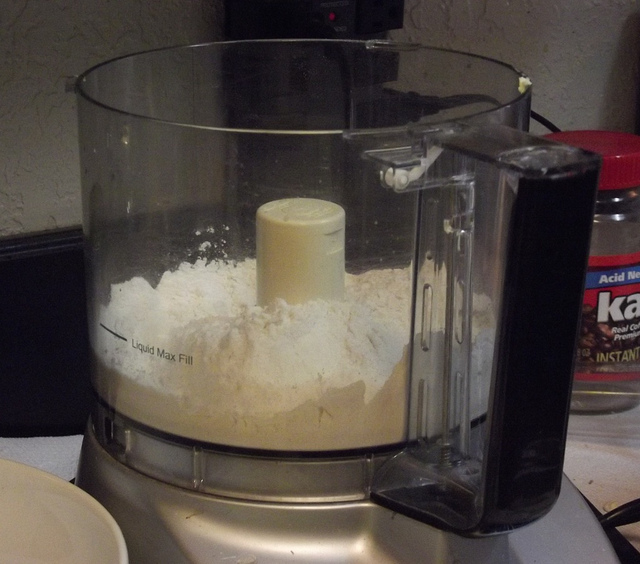<image>What is the brand name of the blender? I don't know the brand name of the blender. However, options are 'liquid max', 'logic max', 'kenmore', 'kitchenaid', 'corning', or 'whirlpool'. What is the brand name of the blender? It is unknown what the brand name of the blender is. However, it can be seen 'liquid max', 'logic max', 'kenmore', 'kitchenaid', 'corning', or 'whirlpool'. 